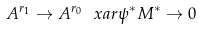Convert formula to latex. <formula><loc_0><loc_0><loc_500><loc_500>A ^ { r _ { 1 } } \to A ^ { r _ { 0 } } \ x a r { \psi ^ { * } } M ^ { * } \to 0</formula> 